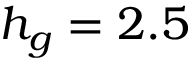<formula> <loc_0><loc_0><loc_500><loc_500>h _ { g } = 2 . 5</formula> 